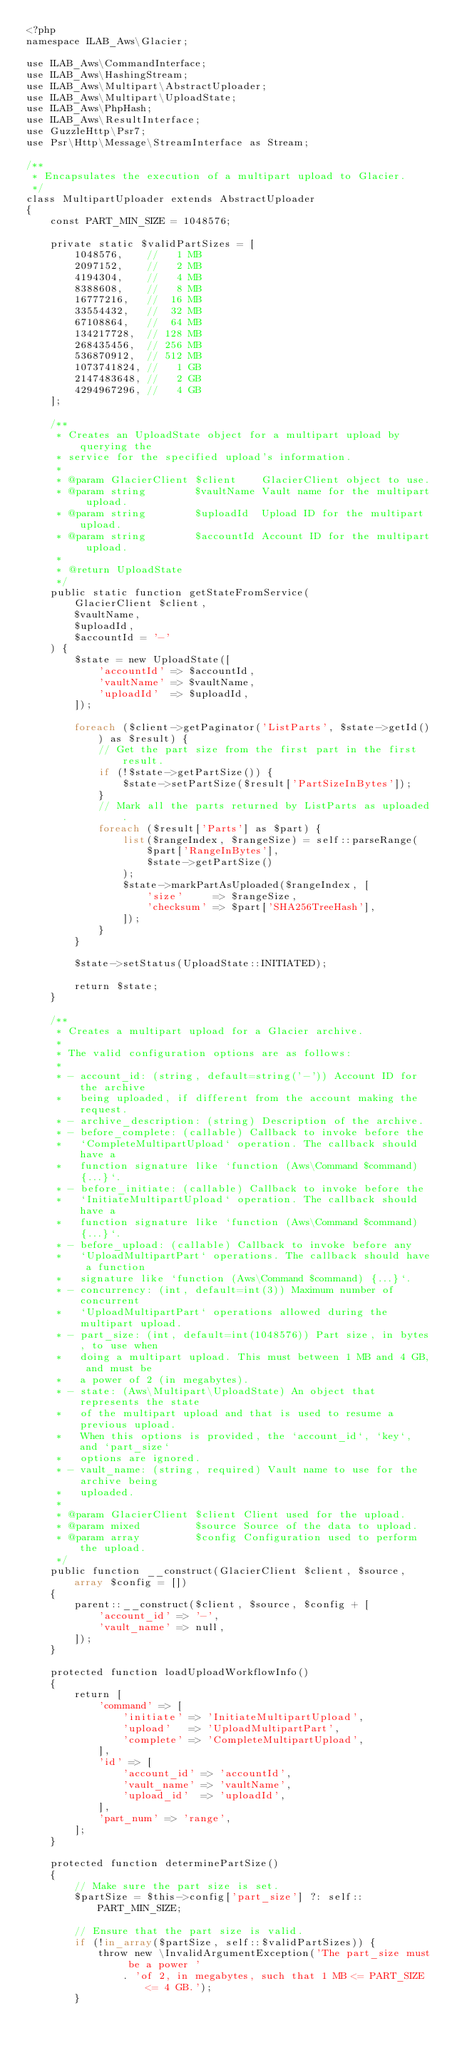<code> <loc_0><loc_0><loc_500><loc_500><_PHP_><?php
namespace ILAB_Aws\Glacier;

use ILAB_Aws\CommandInterface;
use ILAB_Aws\HashingStream;
use ILAB_Aws\Multipart\AbstractUploader;
use ILAB_Aws\Multipart\UploadState;
use ILAB_Aws\PhpHash;
use ILAB_Aws\ResultInterface;
use GuzzleHttp\Psr7;
use Psr\Http\Message\StreamInterface as Stream;

/**
 * Encapsulates the execution of a multipart upload to Glacier.
 */
class MultipartUploader extends AbstractUploader
{
    const PART_MIN_SIZE = 1048576;

    private static $validPartSizes = [
        1048576,    //   1 MB
        2097152,    //   2 MB
        4194304,    //   4 MB
        8388608,    //   8 MB
        16777216,   //  16 MB
        33554432,   //  32 MB
        67108864,   //  64 MB
        134217728,  // 128 MB
        268435456,  // 256 MB
        536870912,  // 512 MB
        1073741824, //   1 GB
        2147483648, //   2 GB
        4294967296, //   4 GB
    ];

    /**
     * Creates an UploadState object for a multipart upload by querying the
     * service for the specified upload's information.
     *
     * @param GlacierClient $client    GlacierClient object to use.
     * @param string        $vaultName Vault name for the multipart upload.
     * @param string        $uploadId  Upload ID for the multipart upload.
     * @param string        $accountId Account ID for the multipart upload.
     *
     * @return UploadState
     */
    public static function getStateFromService(
        GlacierClient $client,
        $vaultName,
        $uploadId,
        $accountId = '-'
    ) {
        $state = new UploadState([
            'accountId' => $accountId,
            'vaultName' => $vaultName,
            'uploadId'  => $uploadId,
        ]);

        foreach ($client->getPaginator('ListParts', $state->getId()) as $result) {
            // Get the part size from the first part in the first result.
            if (!$state->getPartSize()) {
                $state->setPartSize($result['PartSizeInBytes']);
            }
            // Mark all the parts returned by ListParts as uploaded.
            foreach ($result['Parts'] as $part) {
                list($rangeIndex, $rangeSize) = self::parseRange(
                    $part['RangeInBytes'],
                    $state->getPartSize()
                );
                $state->markPartAsUploaded($rangeIndex, [
                    'size'     => $rangeSize,
                    'checksum' => $part['SHA256TreeHash'],
                ]);
            }
        }

        $state->setStatus(UploadState::INITIATED);

        return $state;
    }

    /**
     * Creates a multipart upload for a Glacier archive.
     *
     * The valid configuration options are as follows:
     *
     * - account_id: (string, default=string('-')) Account ID for the archive
     *   being uploaded, if different from the account making the request.
     * - archive_description: (string) Description of the archive.
     * - before_complete: (callable) Callback to invoke before the
     *   `CompleteMultipartUpload` operation. The callback should have a
     *   function signature like `function (Aws\Command $command) {...}`.
     * - before_initiate: (callable) Callback to invoke before the
     *   `InitiateMultipartUpload` operation. The callback should have a
     *   function signature like `function (Aws\Command $command) {...}`.
     * - before_upload: (callable) Callback to invoke before any
     *   `UploadMultipartPart` operations. The callback should have a function
     *   signature like `function (Aws\Command $command) {...}`.
     * - concurrency: (int, default=int(3)) Maximum number of concurrent
     *   `UploadMultipartPart` operations allowed during the multipart upload.
     * - part_size: (int, default=int(1048576)) Part size, in bytes, to use when
     *   doing a multipart upload. This must between 1 MB and 4 GB, and must be
     *   a power of 2 (in megabytes).
     * - state: (Aws\Multipart\UploadState) An object that represents the state
     *   of the multipart upload and that is used to resume a previous upload.
     *   When this options is provided, the `account_id`, `key`, and `part_size`
     *   options are ignored.
     * - vault_name: (string, required) Vault name to use for the archive being
     *   uploaded.
     *
     * @param GlacierClient $client Client used for the upload.
     * @param mixed         $source Source of the data to upload.
     * @param array         $config Configuration used to perform the upload.
     */
    public function __construct(GlacierClient $client, $source, array $config = [])
    {
        parent::__construct($client, $source, $config + [
            'account_id' => '-',
            'vault_name' => null,
        ]);
    }

    protected function loadUploadWorkflowInfo()
    {
        return [
            'command' => [
                'initiate' => 'InitiateMultipartUpload',
                'upload'   => 'UploadMultipartPart',
                'complete' => 'CompleteMultipartUpload',
            ],
            'id' => [
                'account_id' => 'accountId',
                'vault_name' => 'vaultName',
                'upload_id'  => 'uploadId',
            ],
            'part_num' => 'range',
        ];
    }

    protected function determinePartSize()
    {
        // Make sure the part size is set.
        $partSize = $this->config['part_size'] ?: self::PART_MIN_SIZE;

        // Ensure that the part size is valid.
        if (!in_array($partSize, self::$validPartSizes)) {
            throw new \InvalidArgumentException('The part_size must be a power '
                . 'of 2, in megabytes, such that 1 MB <= PART_SIZE <= 4 GB.');
        }
</code> 